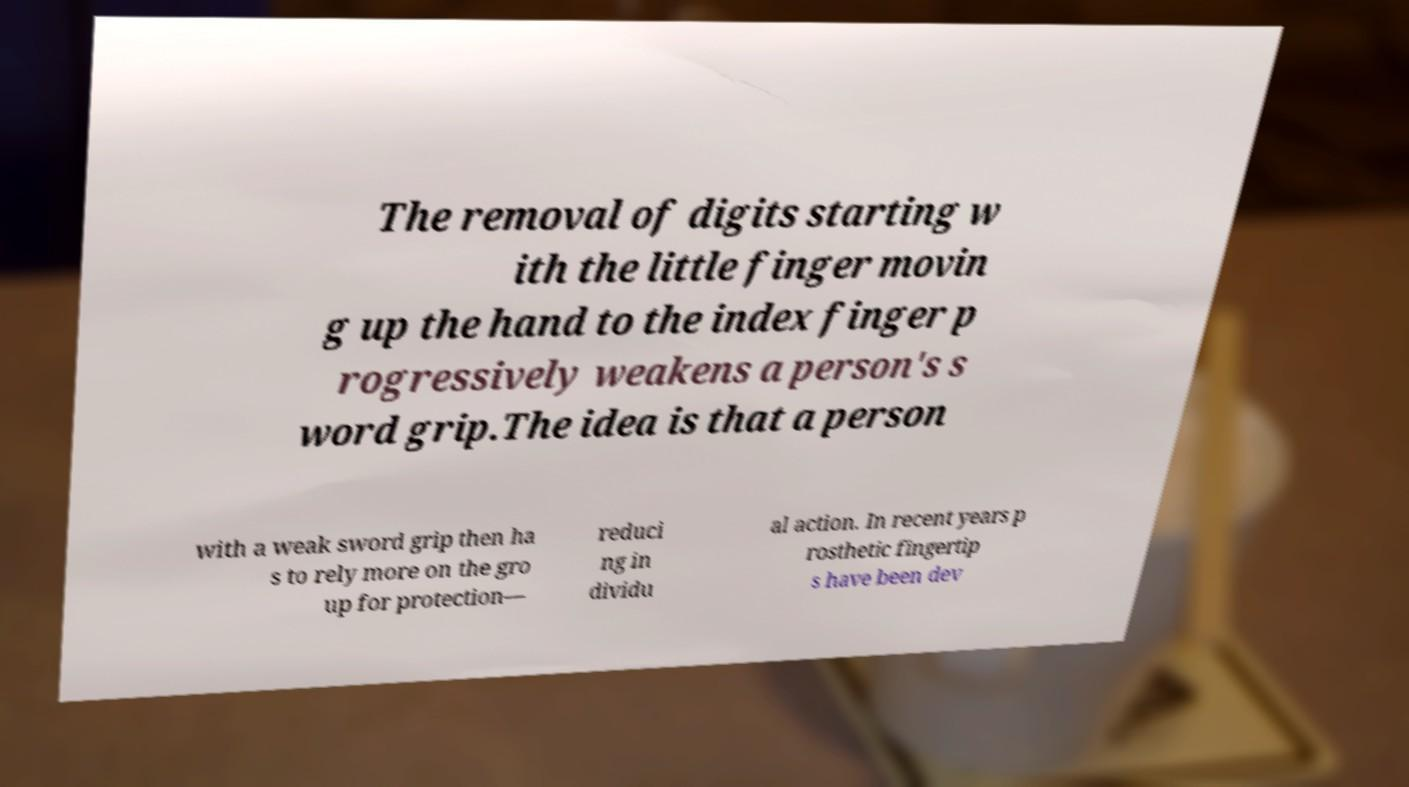What messages or text are displayed in this image? I need them in a readable, typed format. The removal of digits starting w ith the little finger movin g up the hand to the index finger p rogressively weakens a person's s word grip.The idea is that a person with a weak sword grip then ha s to rely more on the gro up for protection— reduci ng in dividu al action. In recent years p rosthetic fingertip s have been dev 